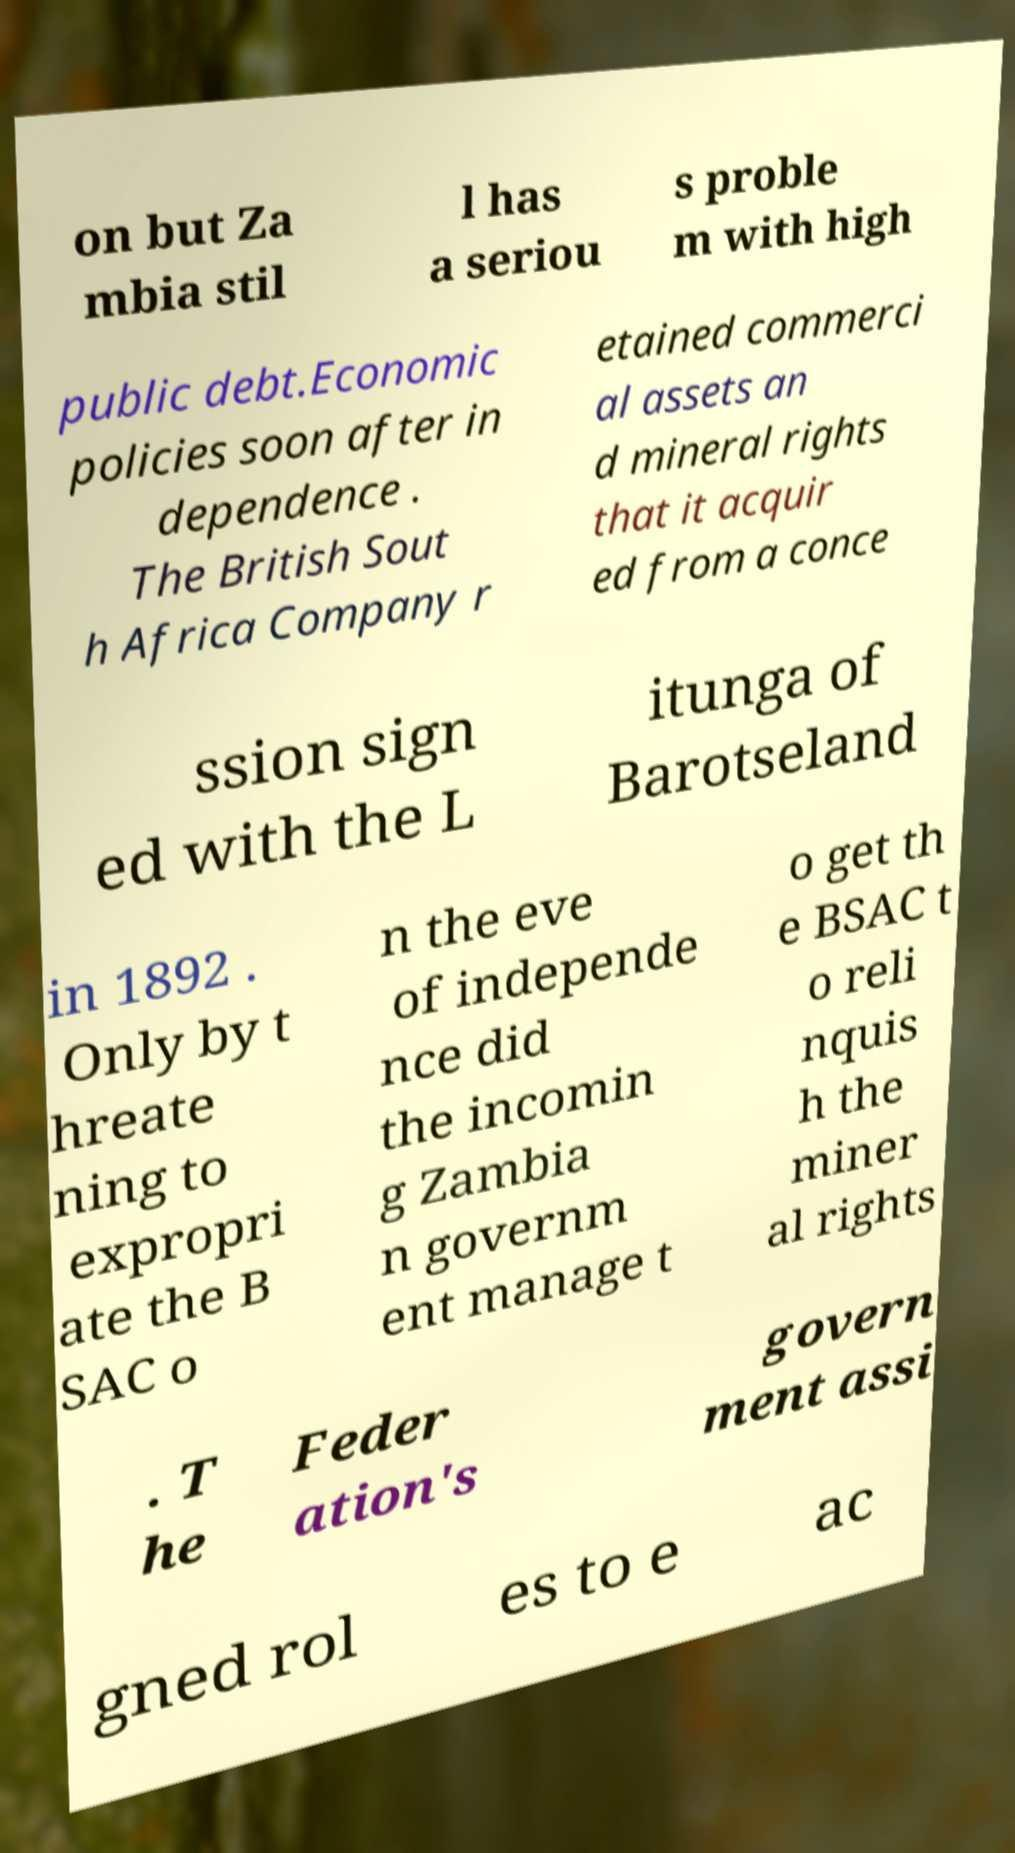What messages or text are displayed in this image? I need them in a readable, typed format. on but Za mbia stil l has a seriou s proble m with high public debt.Economic policies soon after in dependence . The British Sout h Africa Company r etained commerci al assets an d mineral rights that it acquir ed from a conce ssion sign ed with the L itunga of Barotseland in 1892 . Only by t hreate ning to expropri ate the B SAC o n the eve of independe nce did the incomin g Zambia n governm ent manage t o get th e BSAC t o reli nquis h the miner al rights . T he Feder ation's govern ment assi gned rol es to e ac 